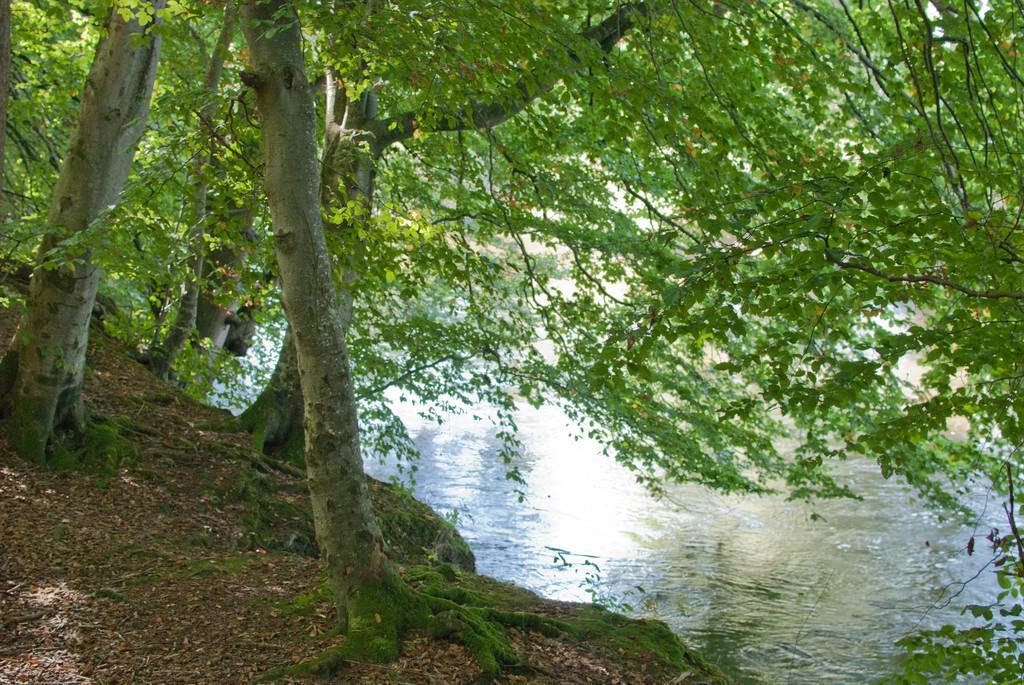How would you summarize this image in a sentence or two? In this image there is the river, there are trees, there is soil, there are plants. 